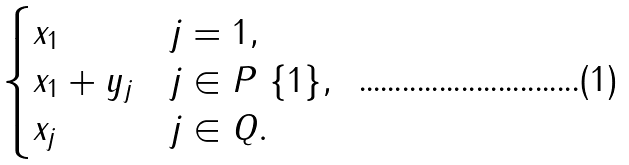Convert formula to latex. <formula><loc_0><loc_0><loc_500><loc_500>\begin{cases} x _ { 1 } & j = 1 , \\ x _ { 1 } + y _ { j } & j \in P \ \{ 1 \} , \\ x _ { j } & j \in Q . \end{cases}</formula> 